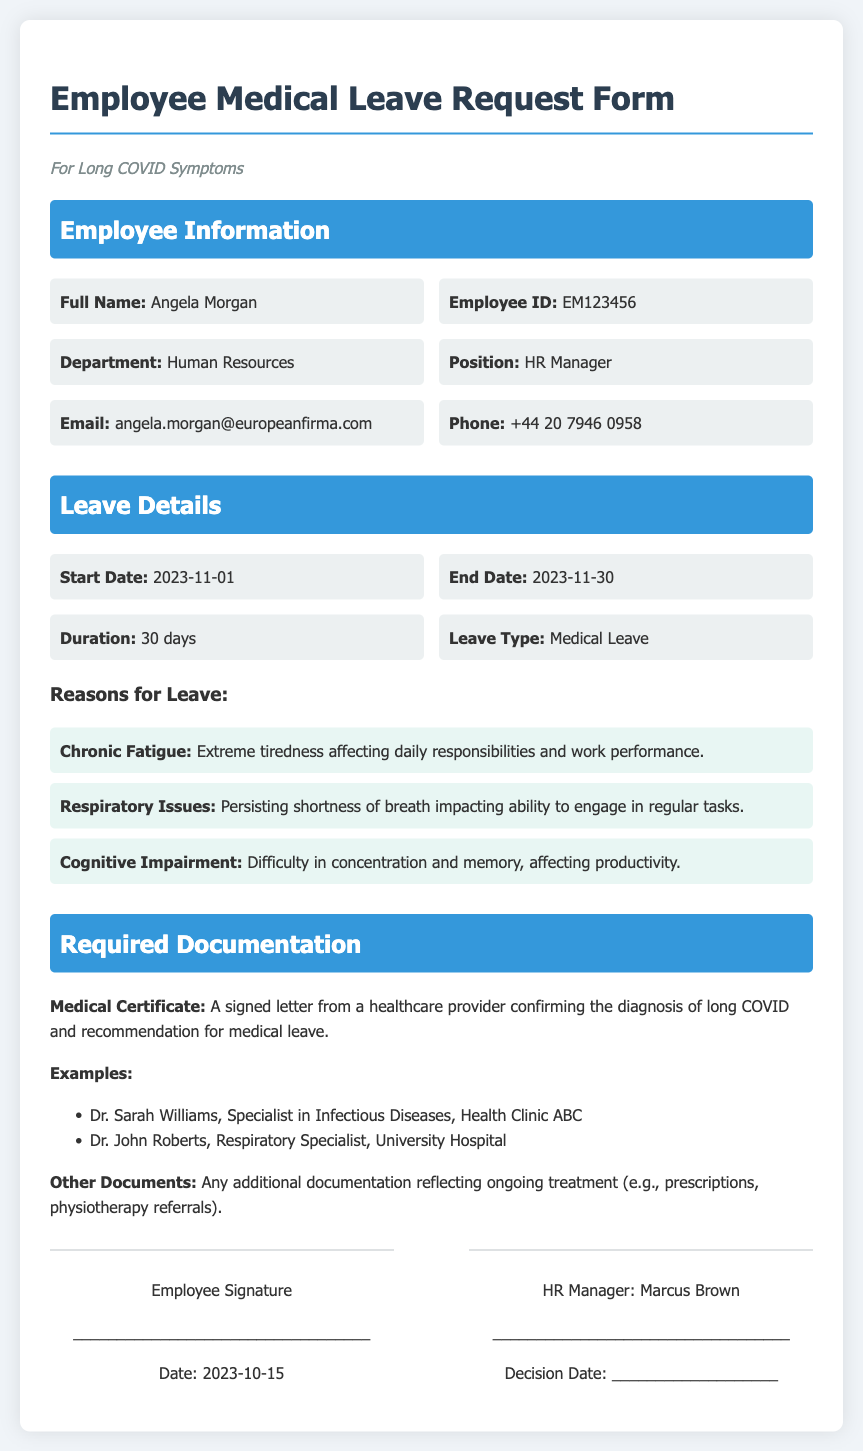What is the employee's full name? The employee's full name is listed in the Employee Information section of the document.
Answer: Angela Morgan What is the employee ID? The employee ID is provided alongside the employee's name in the document.
Answer: EM123456 What is the leave start date? The leave start date is mentioned in the Leave Details section.
Answer: 2023-11-01 What is the duration of the leave? The duration of the leave is specified in the Leave Details section.
Answer: 30 days What reasons are listed for the leave? The reasons for leave are detailed under the Leave Details section, which includes multiple symptoms.
Answer: Chronic Fatigue, Respiratory Issues, Cognitive Impairment Who is the HR Manager mentioned in the document? The HR Manager's name is provided in the signature section of the document.
Answer: Marcus Brown What type of leave is being requested? The type of leave is noted in the Leave Details section.
Answer: Medical Leave What is required as medical documentation? Required documentation is outlined in the Required Documentation section.
Answer: Medical Certificate Which doctor is a specialist listed for medical documentation? The document lists specific specialists who can provide medical documentation.
Answer: Dr. Sarah Williams What is the decision date section used for? The decision date section is meant for recording the date when the HR Manager makes a decision on the leave request.
Answer: Decision Date: ___________________ 